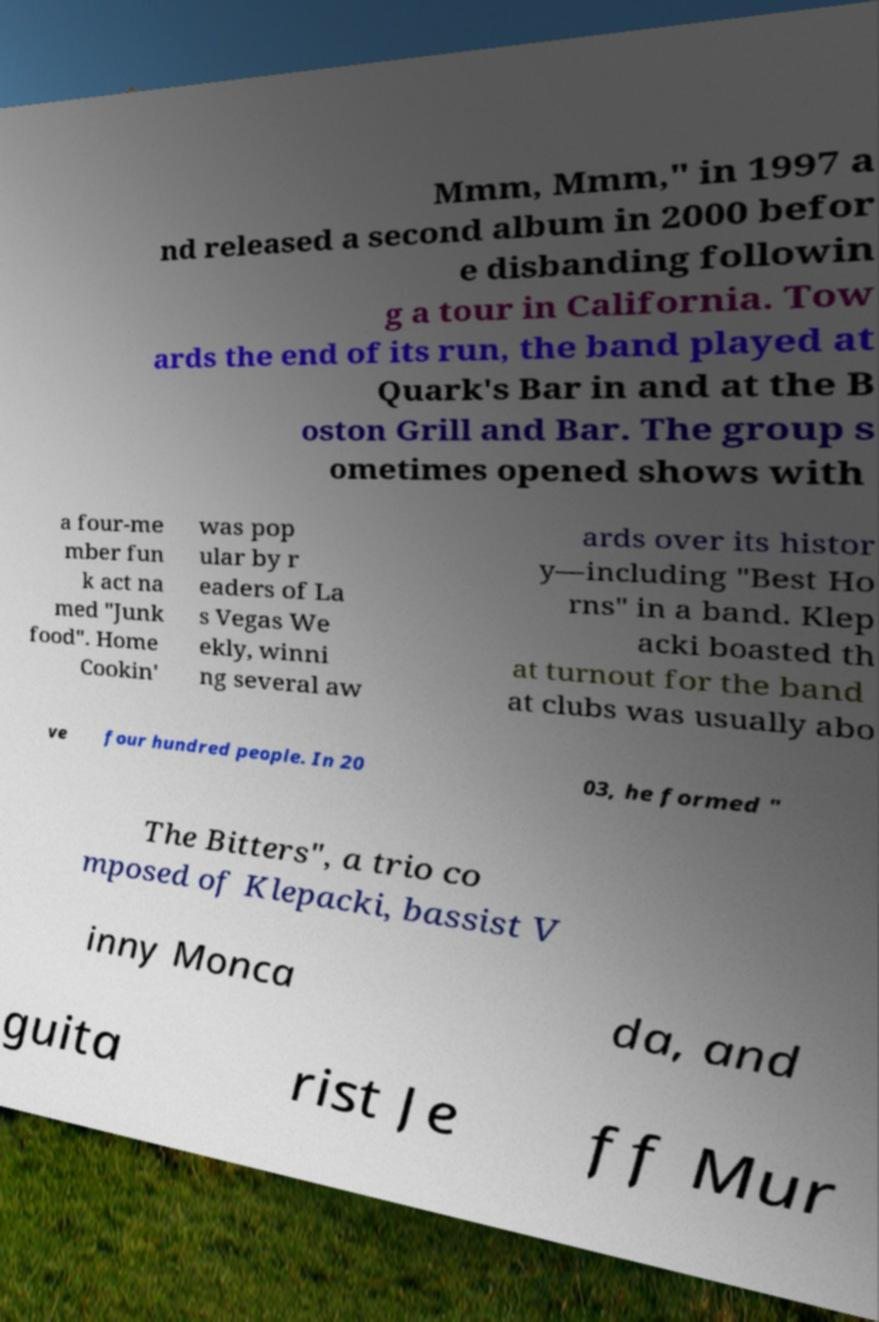Can you accurately transcribe the text from the provided image for me? Mmm, Mmm," in 1997 a nd released a second album in 2000 befor e disbanding followin g a tour in California. Tow ards the end of its run, the band played at Quark's Bar in and at the B oston Grill and Bar. The group s ometimes opened shows with a four-me mber fun k act na med "Junk food". Home Cookin' was pop ular by r eaders of La s Vegas We ekly, winni ng several aw ards over its histor y—including "Best Ho rns" in a band. Klep acki boasted th at turnout for the band at clubs was usually abo ve four hundred people. In 20 03, he formed " The Bitters", a trio co mposed of Klepacki, bassist V inny Monca da, and guita rist Je ff Mur 